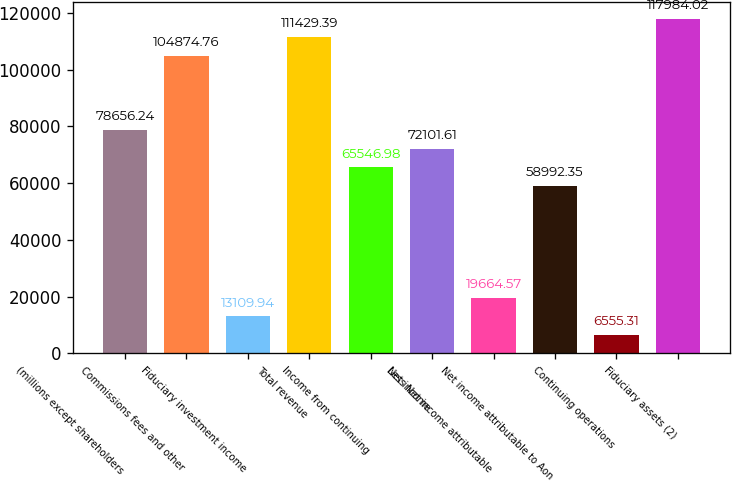Convert chart to OTSL. <chart><loc_0><loc_0><loc_500><loc_500><bar_chart><fcel>(millions except shareholders<fcel>Commissions fees and other<fcel>Fiduciary investment income<fcel>Total revenue<fcel>Income from continuing<fcel>Net income<fcel>Less Net income attributable<fcel>Net income attributable to Aon<fcel>Continuing operations<fcel>Fiduciary assets (2)<nl><fcel>78656.2<fcel>104875<fcel>13109.9<fcel>111429<fcel>65547<fcel>72101.6<fcel>19664.6<fcel>58992.3<fcel>6555.31<fcel>117984<nl></chart> 